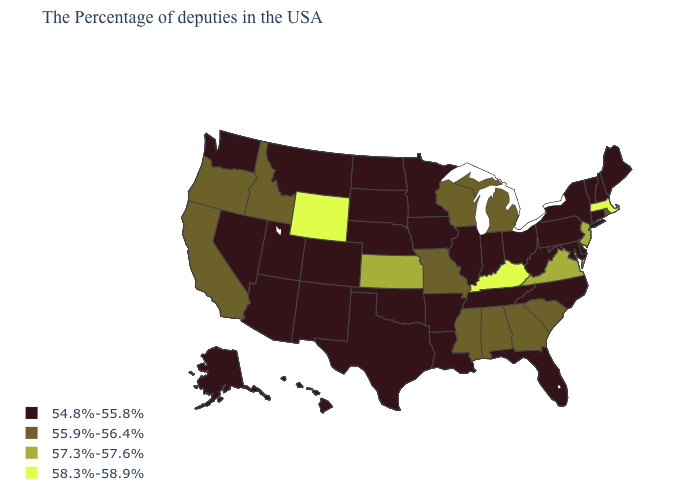Name the states that have a value in the range 57.3%-57.6%?
Concise answer only. New Jersey, Virginia, Kansas. What is the value of Indiana?
Concise answer only. 54.8%-55.8%. Name the states that have a value in the range 54.8%-55.8%?
Answer briefly. Maine, New Hampshire, Vermont, Connecticut, New York, Delaware, Maryland, Pennsylvania, North Carolina, West Virginia, Ohio, Florida, Indiana, Tennessee, Illinois, Louisiana, Arkansas, Minnesota, Iowa, Nebraska, Oklahoma, Texas, South Dakota, North Dakota, Colorado, New Mexico, Utah, Montana, Arizona, Nevada, Washington, Alaska, Hawaii. Name the states that have a value in the range 57.3%-57.6%?
Short answer required. New Jersey, Virginia, Kansas. Which states have the highest value in the USA?
Quick response, please. Massachusetts, Kentucky, Wyoming. Among the states that border Oklahoma , which have the highest value?
Write a very short answer. Kansas. Does Wyoming have the same value as Kentucky?
Concise answer only. Yes. Does Wyoming have the lowest value in the USA?
Quick response, please. No. Name the states that have a value in the range 58.3%-58.9%?
Give a very brief answer. Massachusetts, Kentucky, Wyoming. Which states hav the highest value in the West?
Short answer required. Wyoming. Among the states that border Connecticut , which have the highest value?
Answer briefly. Massachusetts. Is the legend a continuous bar?
Write a very short answer. No. Does Massachusetts have the lowest value in the Northeast?
Quick response, please. No. Name the states that have a value in the range 57.3%-57.6%?
Be succinct. New Jersey, Virginia, Kansas. Which states hav the highest value in the MidWest?
Short answer required. Kansas. 